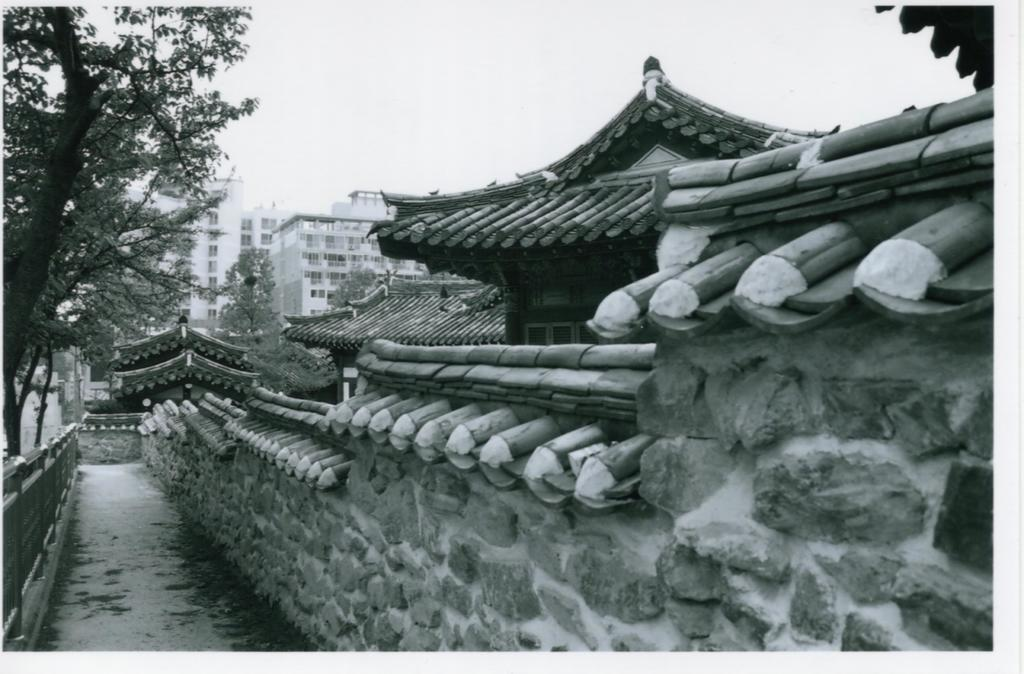What can be seen on the left side of the image? There is a path on the left side of the image. What is located beside the path? There is a wall beside the path. What is visible in the background of the image? Buildings are visible in the background of the image. What type of vegetation is present on either side of the path? Trees are present on either side of the path. What is visible above the path? The sky is visible above the path. Can you tell me how many oranges are hanging from the trees on either side of the path? There are no oranges present in the image; only trees are visible on either side of the path. Is there a goat or a cow visible in the image? No, there are no goats or cows present in the image. 